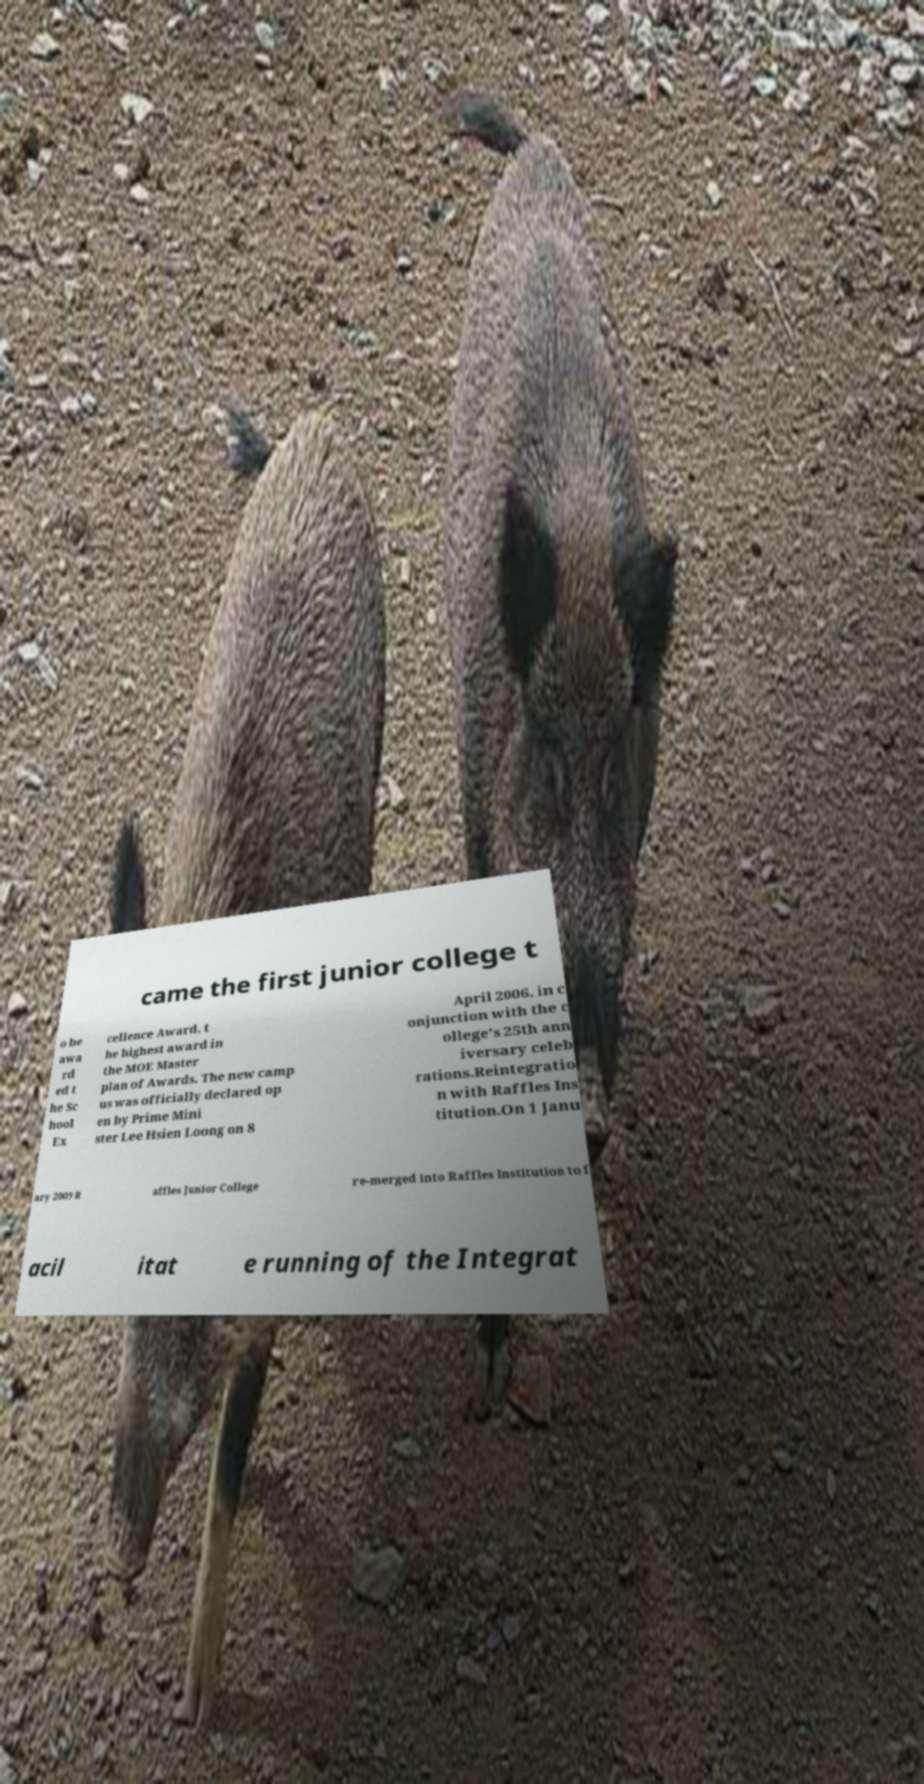Could you extract and type out the text from this image? came the first junior college t o be awa rd ed t he Sc hool Ex cellence Award, t he highest award in the MOE Master plan of Awards. The new camp us was officially declared op en by Prime Mini ster Lee Hsien Loong on 8 April 2006, in c onjunction with the c ollege's 25th ann iversary celeb rations.Reintegratio n with Raffles Ins titution.On 1 Janu ary 2009 R affles Junior College re-merged into Raffles Institution to f acil itat e running of the Integrat 